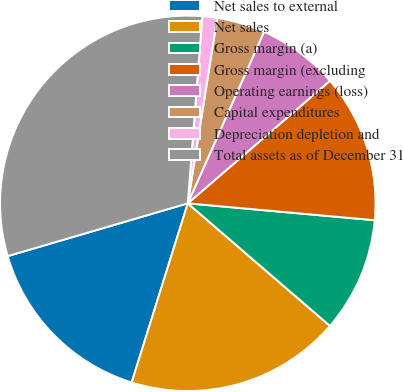Convert chart to OTSL. <chart><loc_0><loc_0><loc_500><loc_500><pie_chart><fcel>Net sales to external<fcel>Net sales<fcel>Gross margin (a)<fcel>Gross margin (excluding<fcel>Operating earnings (loss)<fcel>Capital expenditures<fcel>Depreciation depletion and<fcel>Total assets as of December 31<nl><fcel>15.63%<fcel>18.51%<fcel>9.89%<fcel>12.76%<fcel>7.02%<fcel>4.15%<fcel>1.27%<fcel>30.77%<nl></chart> 